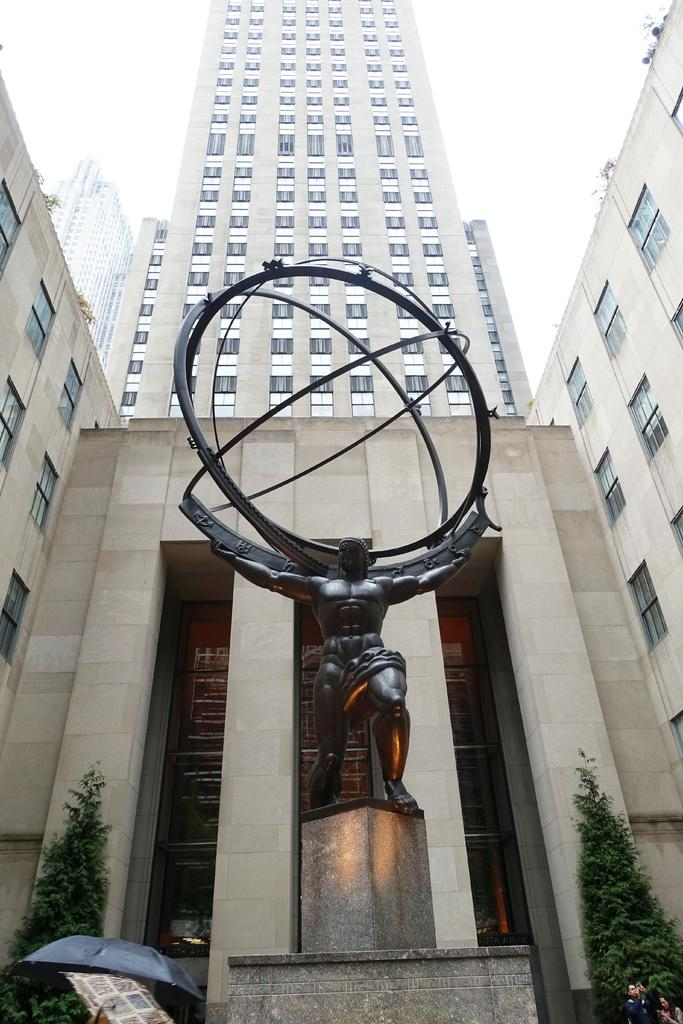What type of structures can be seen in the image? There are buildings in the image. What other natural elements are present in the image? There are trees in the image. What is located at the front of the image? There is a statue in the front of the image. What can be seen in the distance in the image? The sky is visible in the background of the image. How many visitors can be seen interacting with the statue in the image? There is no mention of visitors in the image; it only features the statue, buildings, trees, and the sky. 